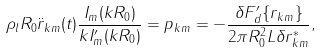<formula> <loc_0><loc_0><loc_500><loc_500>\rho _ { l } R _ { 0 } \ddot { r } _ { k m } ( t ) \frac { I _ { m } ( k R _ { 0 } ) } { k I _ { m } ^ { \prime } ( k R _ { 0 } ) } = p _ { k m } = - \frac { \delta F _ { d } ^ { \prime } \{ r _ { k m } \} } { 2 \pi R _ { 0 } ^ { 2 } L \delta r _ { k m } ^ { * } } ,</formula> 